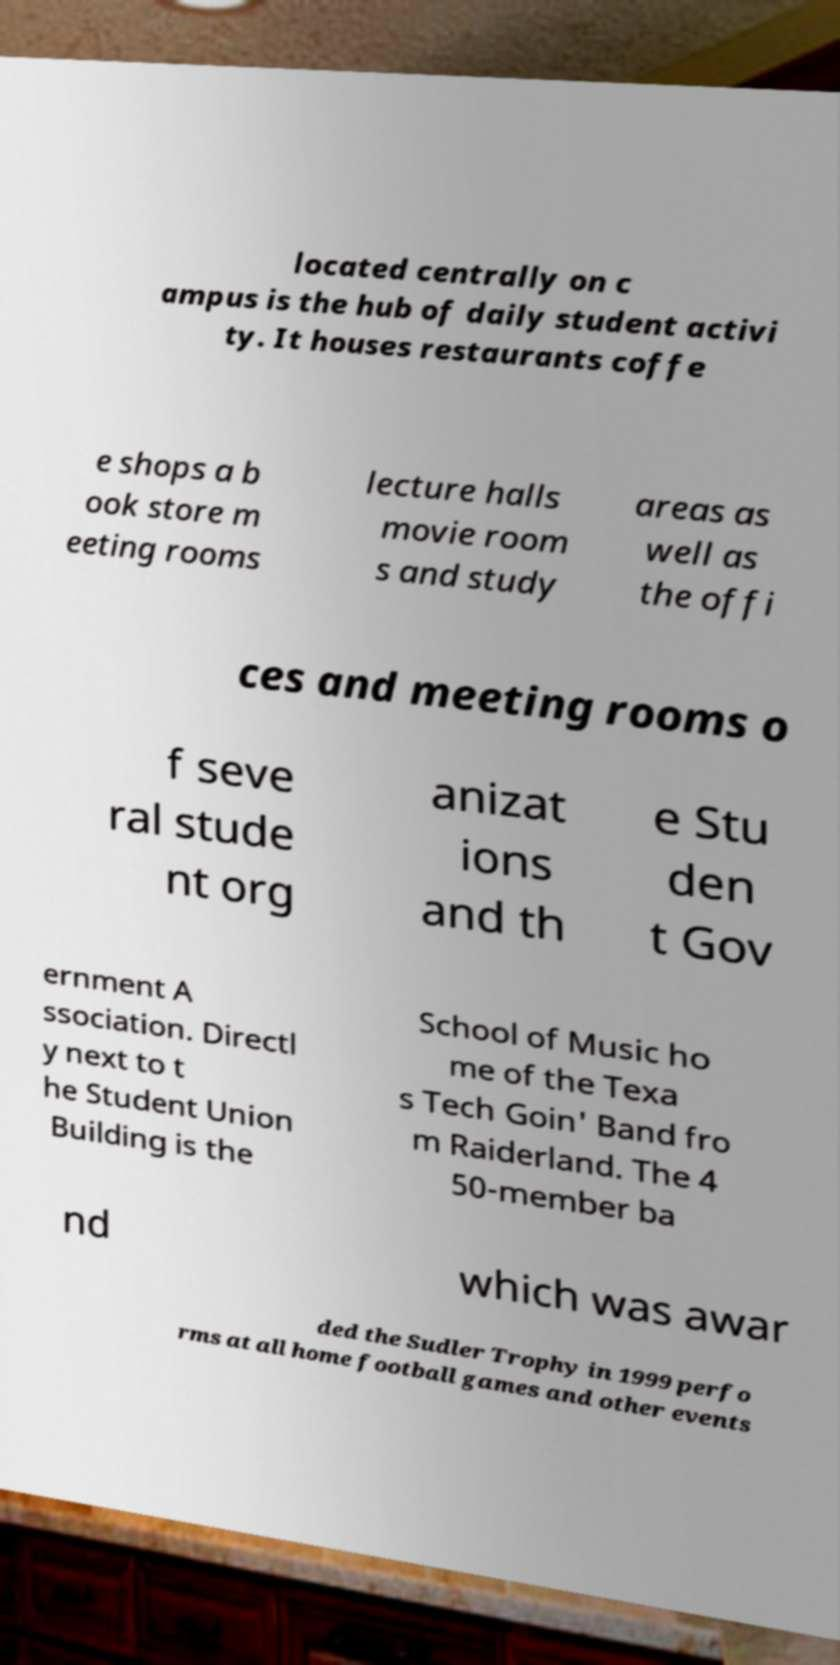What messages or text are displayed in this image? I need them in a readable, typed format. located centrally on c ampus is the hub of daily student activi ty. It houses restaurants coffe e shops a b ook store m eeting rooms lecture halls movie room s and study areas as well as the offi ces and meeting rooms o f seve ral stude nt org anizat ions and th e Stu den t Gov ernment A ssociation. Directl y next to t he Student Union Building is the School of Music ho me of the Texa s Tech Goin' Band fro m Raiderland. The 4 50-member ba nd which was awar ded the Sudler Trophy in 1999 perfo rms at all home football games and other events 